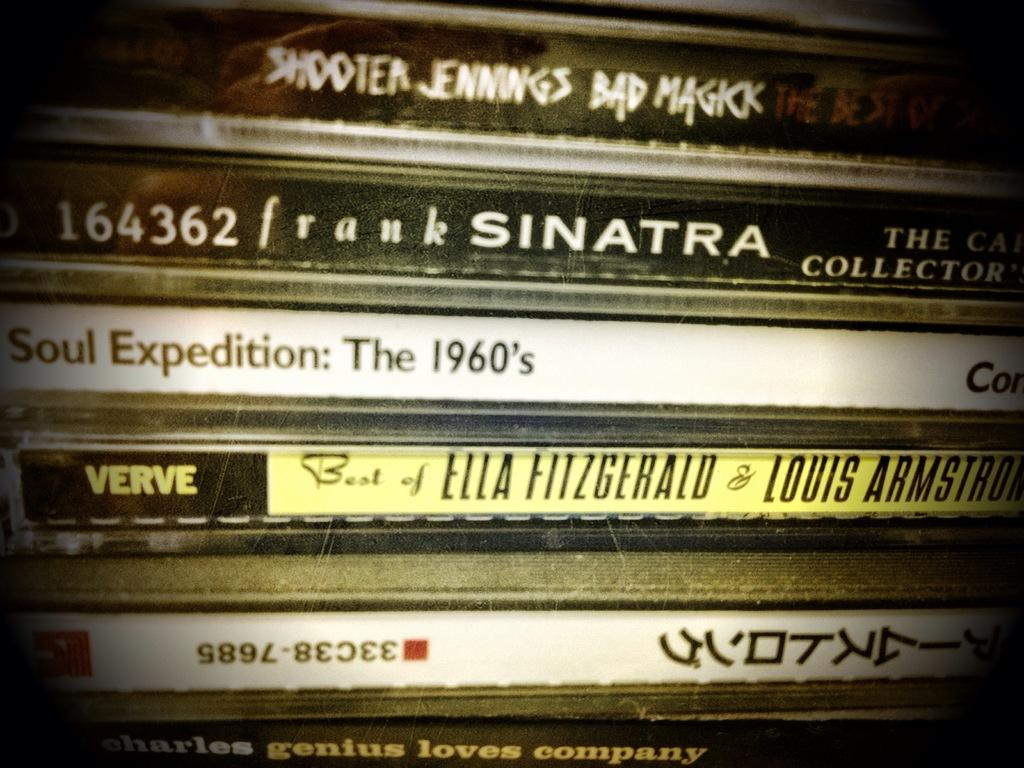<image>
Provide a brief description of the given image. A stack of CDs including one of Frank Sinatra. 